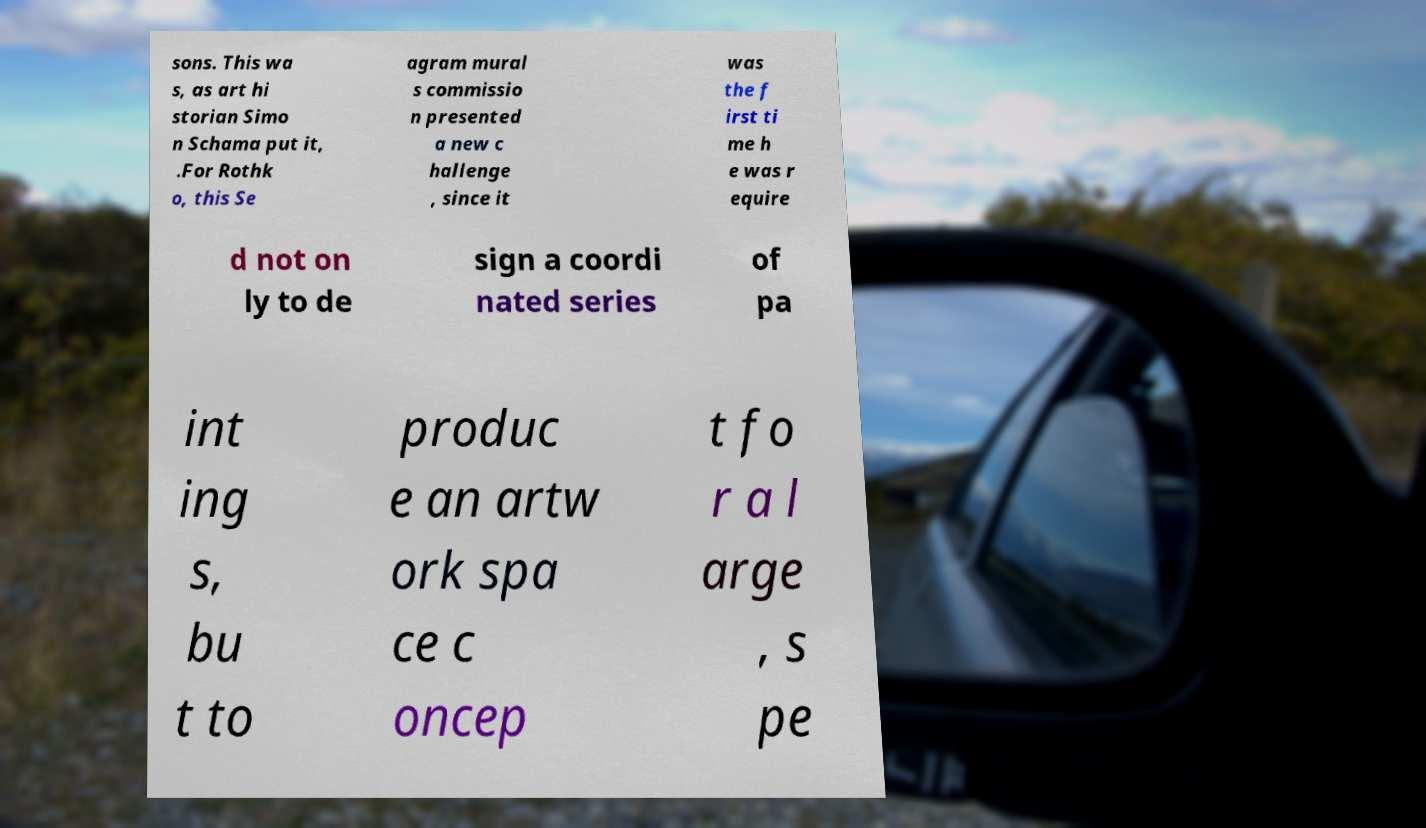Could you extract and type out the text from this image? sons. This wa s, as art hi storian Simo n Schama put it, .For Rothk o, this Se agram mural s commissio n presented a new c hallenge , since it was the f irst ti me h e was r equire d not on ly to de sign a coordi nated series of pa int ing s, bu t to produc e an artw ork spa ce c oncep t fo r a l arge , s pe 